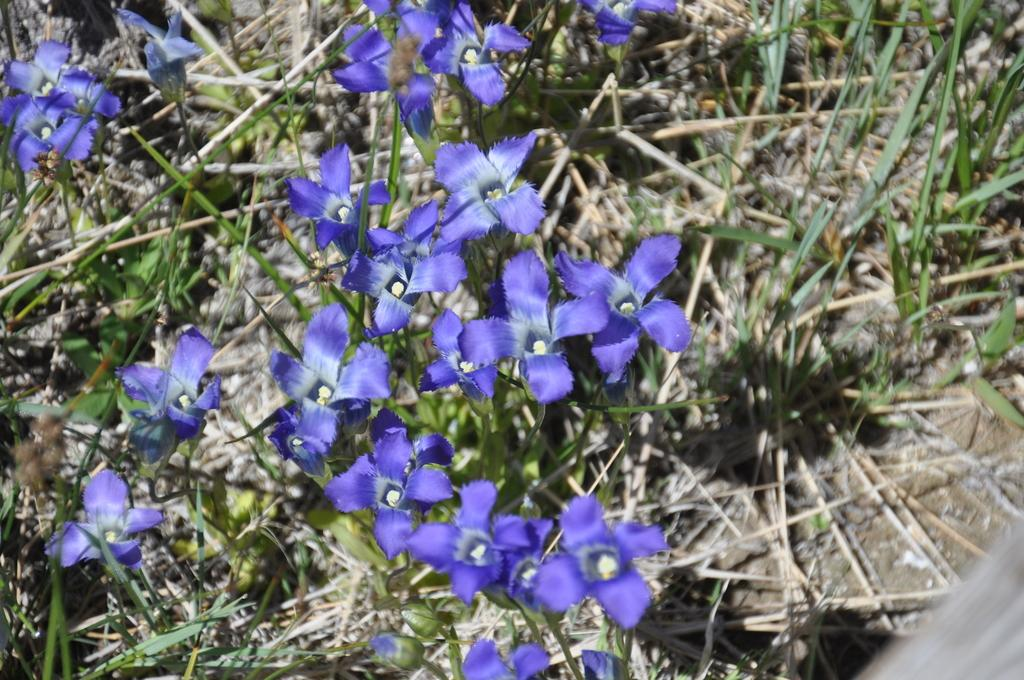What is the main subject of the image? The main subject of the image is a group of flowers. Where are the flowers located? The flowers are on plants. What can be seen in the background of the image? There is grass visible in the background of the image. What type of fish can be seen swimming in the flowers in the image? There are no fish present in the image; it features a group of flowers on plants with grass visible in the background. 